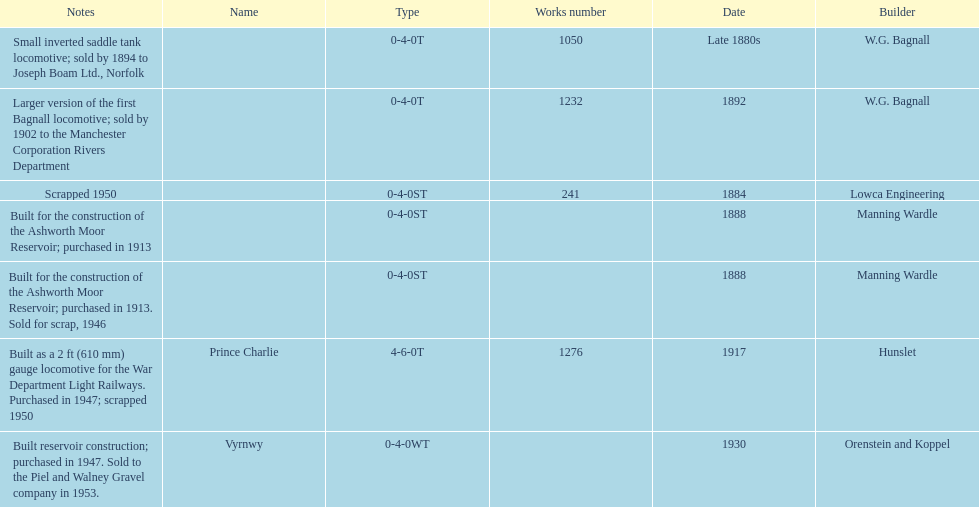Who built the larger version of the first bagnall locomotive? W.G. Bagnall. 